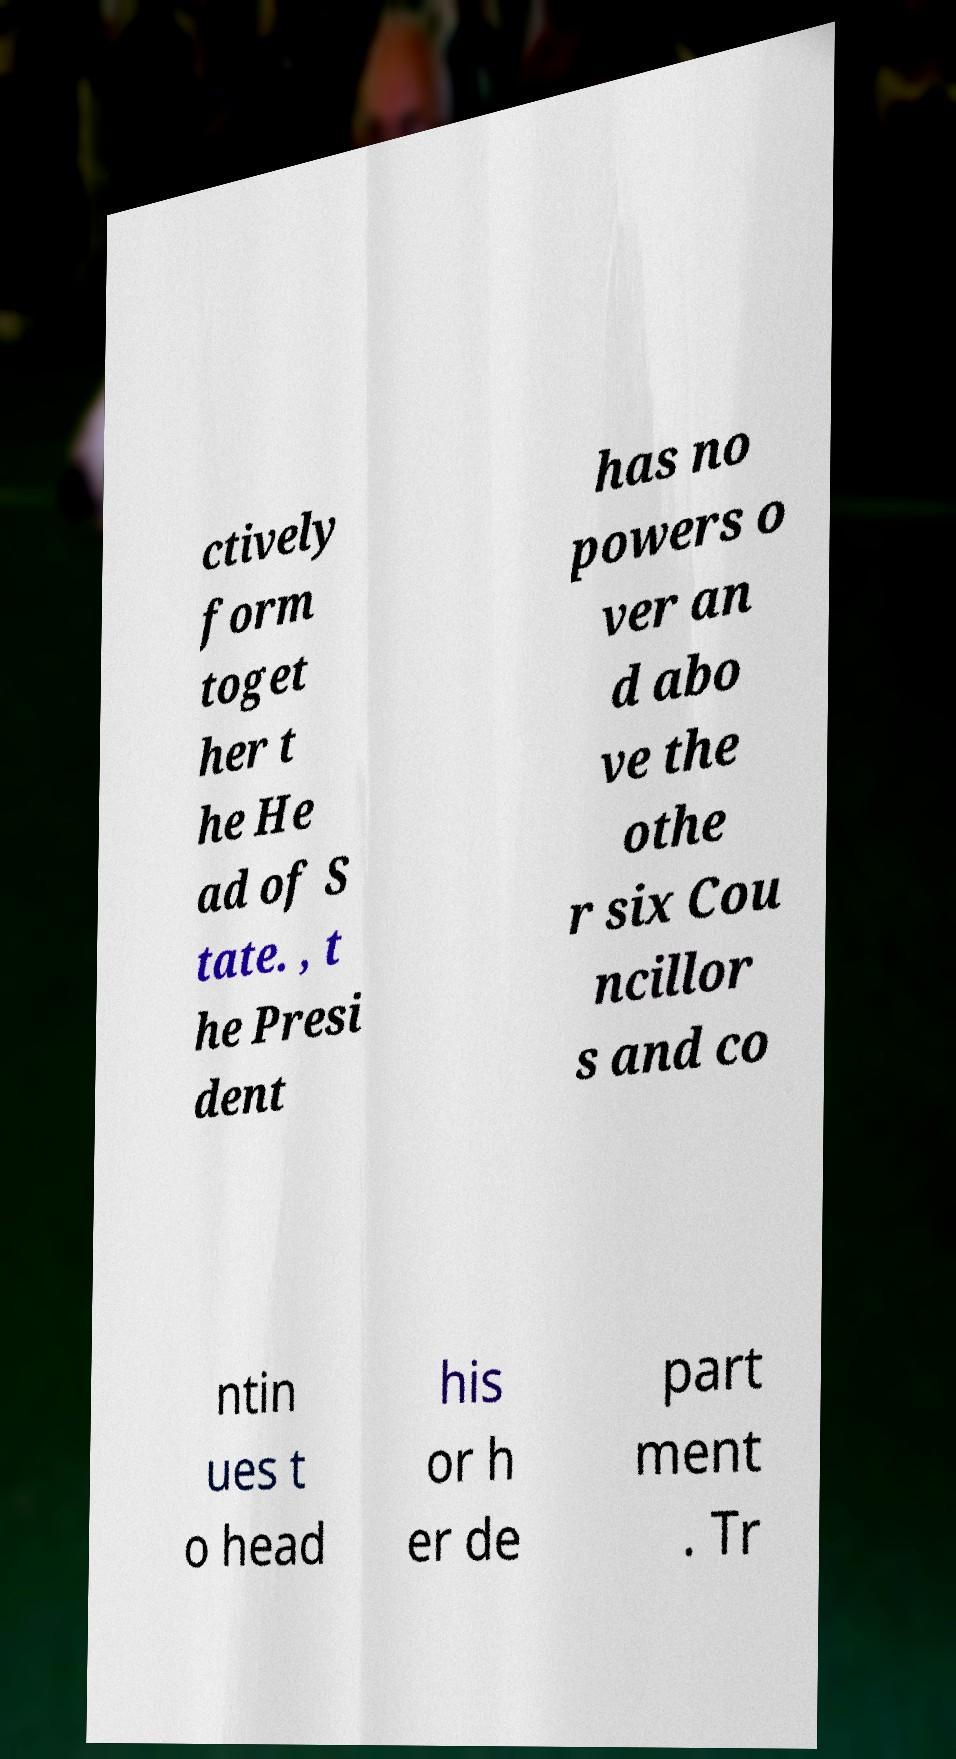There's text embedded in this image that I need extracted. Can you transcribe it verbatim? ctively form toget her t he He ad of S tate. , t he Presi dent has no powers o ver an d abo ve the othe r six Cou ncillor s and co ntin ues t o head his or h er de part ment . Tr 